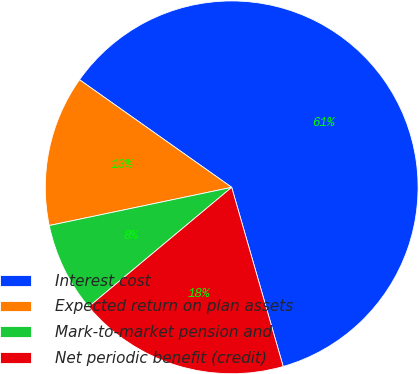Convert chart. <chart><loc_0><loc_0><loc_500><loc_500><pie_chart><fcel>Interest cost<fcel>Expected return on plan assets<fcel>Mark-to-market pension and<fcel>Net periodic benefit (credit)<nl><fcel>60.75%<fcel>13.08%<fcel>7.79%<fcel>18.38%<nl></chart> 